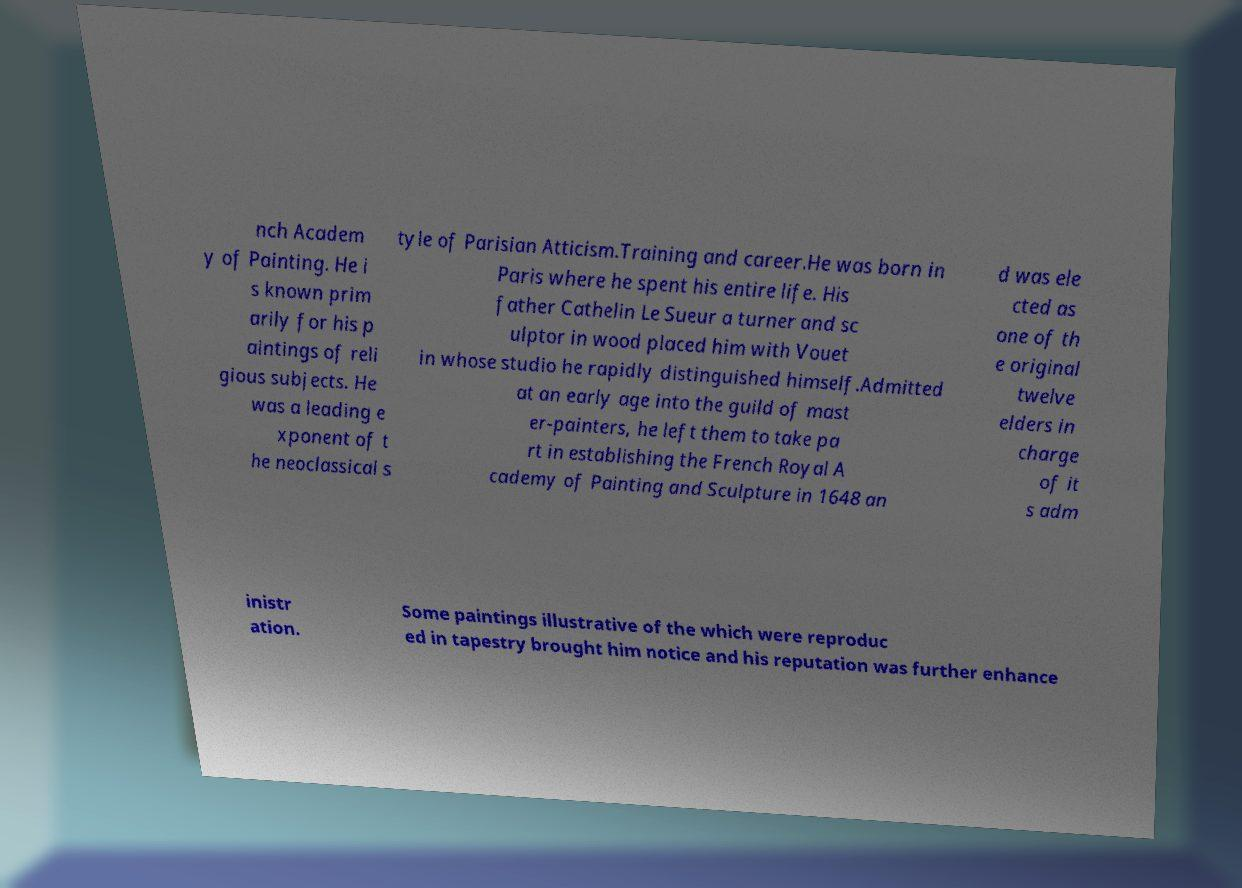For documentation purposes, I need the text within this image transcribed. Could you provide that? nch Academ y of Painting. He i s known prim arily for his p aintings of reli gious subjects. He was a leading e xponent of t he neoclassical s tyle of Parisian Atticism.Training and career.He was born in Paris where he spent his entire life. His father Cathelin Le Sueur a turner and sc ulptor in wood placed him with Vouet in whose studio he rapidly distinguished himself.Admitted at an early age into the guild of mast er-painters, he left them to take pa rt in establishing the French Royal A cademy of Painting and Sculpture in 1648 an d was ele cted as one of th e original twelve elders in charge of it s adm inistr ation. Some paintings illustrative of the which were reproduc ed in tapestry brought him notice and his reputation was further enhance 